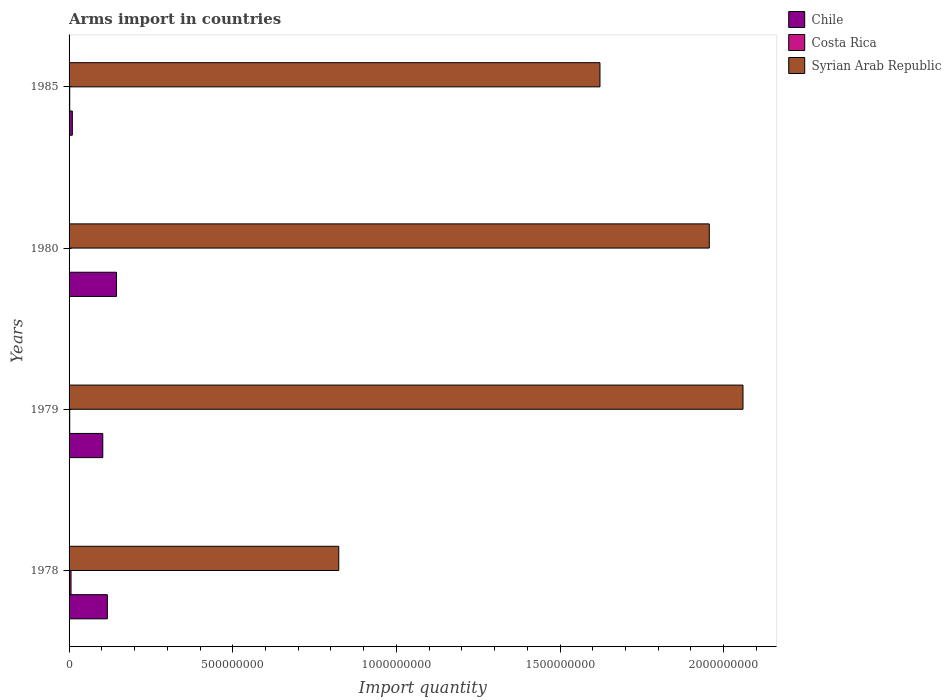How many groups of bars are there?
Offer a very short reply. 4. Are the number of bars per tick equal to the number of legend labels?
Offer a very short reply. Yes. Are the number of bars on each tick of the Y-axis equal?
Offer a terse response. Yes. Across all years, what is the maximum total arms import in Costa Rica?
Your answer should be very brief. 6.00e+06. Across all years, what is the minimum total arms import in Chile?
Provide a succinct answer. 1.00e+07. What is the total total arms import in Syrian Arab Republic in the graph?
Ensure brevity in your answer.  6.46e+09. What is the difference between the total arms import in Chile in 1978 and that in 1979?
Your answer should be compact. 1.40e+07. What is the difference between the total arms import in Chile in 1980 and the total arms import in Costa Rica in 1979?
Provide a succinct answer. 1.43e+08. What is the average total arms import in Costa Rica per year?
Your response must be concise. 2.75e+06. In the year 1978, what is the difference between the total arms import in Costa Rica and total arms import in Chile?
Give a very brief answer. -1.11e+08. Is the total arms import in Costa Rica in 1978 less than that in 1979?
Your answer should be compact. No. What is the difference between the highest and the lowest total arms import in Chile?
Your answer should be very brief. 1.35e+08. Is the sum of the total arms import in Syrian Arab Republic in 1979 and 1980 greater than the maximum total arms import in Costa Rica across all years?
Offer a very short reply. Yes. What does the 1st bar from the bottom in 1980 represents?
Make the answer very short. Chile. Are the values on the major ticks of X-axis written in scientific E-notation?
Your answer should be very brief. No. Does the graph contain grids?
Your answer should be very brief. No. How many legend labels are there?
Provide a short and direct response. 3. How are the legend labels stacked?
Give a very brief answer. Vertical. What is the title of the graph?
Ensure brevity in your answer.  Arms import in countries. Does "Pakistan" appear as one of the legend labels in the graph?
Make the answer very short. No. What is the label or title of the X-axis?
Your response must be concise. Import quantity. What is the label or title of the Y-axis?
Give a very brief answer. Years. What is the Import quantity in Chile in 1978?
Offer a very short reply. 1.17e+08. What is the Import quantity of Syrian Arab Republic in 1978?
Ensure brevity in your answer.  8.24e+08. What is the Import quantity in Chile in 1979?
Offer a terse response. 1.03e+08. What is the Import quantity in Syrian Arab Republic in 1979?
Offer a terse response. 2.06e+09. What is the Import quantity of Chile in 1980?
Your response must be concise. 1.45e+08. What is the Import quantity in Syrian Arab Republic in 1980?
Provide a short and direct response. 1.96e+09. What is the Import quantity in Syrian Arab Republic in 1985?
Your response must be concise. 1.62e+09. Across all years, what is the maximum Import quantity in Chile?
Give a very brief answer. 1.45e+08. Across all years, what is the maximum Import quantity in Costa Rica?
Provide a succinct answer. 6.00e+06. Across all years, what is the maximum Import quantity in Syrian Arab Republic?
Your response must be concise. 2.06e+09. Across all years, what is the minimum Import quantity in Costa Rica?
Provide a short and direct response. 1.00e+06. Across all years, what is the minimum Import quantity of Syrian Arab Republic?
Provide a short and direct response. 8.24e+08. What is the total Import quantity of Chile in the graph?
Keep it short and to the point. 3.75e+08. What is the total Import quantity of Costa Rica in the graph?
Ensure brevity in your answer.  1.10e+07. What is the total Import quantity in Syrian Arab Republic in the graph?
Your response must be concise. 6.46e+09. What is the difference between the Import quantity in Chile in 1978 and that in 1979?
Your answer should be compact. 1.40e+07. What is the difference between the Import quantity of Costa Rica in 1978 and that in 1979?
Provide a short and direct response. 4.00e+06. What is the difference between the Import quantity in Syrian Arab Republic in 1978 and that in 1979?
Make the answer very short. -1.24e+09. What is the difference between the Import quantity in Chile in 1978 and that in 1980?
Offer a terse response. -2.80e+07. What is the difference between the Import quantity of Syrian Arab Republic in 1978 and that in 1980?
Your answer should be very brief. -1.13e+09. What is the difference between the Import quantity of Chile in 1978 and that in 1985?
Keep it short and to the point. 1.07e+08. What is the difference between the Import quantity of Costa Rica in 1978 and that in 1985?
Ensure brevity in your answer.  4.00e+06. What is the difference between the Import quantity of Syrian Arab Republic in 1978 and that in 1985?
Give a very brief answer. -7.98e+08. What is the difference between the Import quantity of Chile in 1979 and that in 1980?
Keep it short and to the point. -4.20e+07. What is the difference between the Import quantity in Syrian Arab Republic in 1979 and that in 1980?
Ensure brevity in your answer.  1.03e+08. What is the difference between the Import quantity in Chile in 1979 and that in 1985?
Offer a very short reply. 9.30e+07. What is the difference between the Import quantity of Costa Rica in 1979 and that in 1985?
Make the answer very short. 0. What is the difference between the Import quantity in Syrian Arab Republic in 1979 and that in 1985?
Keep it short and to the point. 4.37e+08. What is the difference between the Import quantity of Chile in 1980 and that in 1985?
Your response must be concise. 1.35e+08. What is the difference between the Import quantity in Costa Rica in 1980 and that in 1985?
Offer a very short reply. -1.00e+06. What is the difference between the Import quantity in Syrian Arab Republic in 1980 and that in 1985?
Provide a succinct answer. 3.34e+08. What is the difference between the Import quantity in Chile in 1978 and the Import quantity in Costa Rica in 1979?
Offer a very short reply. 1.15e+08. What is the difference between the Import quantity of Chile in 1978 and the Import quantity of Syrian Arab Republic in 1979?
Offer a terse response. -1.94e+09. What is the difference between the Import quantity of Costa Rica in 1978 and the Import quantity of Syrian Arab Republic in 1979?
Provide a short and direct response. -2.05e+09. What is the difference between the Import quantity in Chile in 1978 and the Import quantity in Costa Rica in 1980?
Your response must be concise. 1.16e+08. What is the difference between the Import quantity of Chile in 1978 and the Import quantity of Syrian Arab Republic in 1980?
Provide a succinct answer. -1.84e+09. What is the difference between the Import quantity in Costa Rica in 1978 and the Import quantity in Syrian Arab Republic in 1980?
Give a very brief answer. -1.95e+09. What is the difference between the Import quantity of Chile in 1978 and the Import quantity of Costa Rica in 1985?
Provide a short and direct response. 1.15e+08. What is the difference between the Import quantity in Chile in 1978 and the Import quantity in Syrian Arab Republic in 1985?
Offer a terse response. -1.50e+09. What is the difference between the Import quantity in Costa Rica in 1978 and the Import quantity in Syrian Arab Republic in 1985?
Offer a very short reply. -1.62e+09. What is the difference between the Import quantity in Chile in 1979 and the Import quantity in Costa Rica in 1980?
Give a very brief answer. 1.02e+08. What is the difference between the Import quantity of Chile in 1979 and the Import quantity of Syrian Arab Republic in 1980?
Make the answer very short. -1.85e+09. What is the difference between the Import quantity of Costa Rica in 1979 and the Import quantity of Syrian Arab Republic in 1980?
Your answer should be compact. -1.95e+09. What is the difference between the Import quantity in Chile in 1979 and the Import quantity in Costa Rica in 1985?
Make the answer very short. 1.01e+08. What is the difference between the Import quantity in Chile in 1979 and the Import quantity in Syrian Arab Republic in 1985?
Provide a succinct answer. -1.52e+09. What is the difference between the Import quantity of Costa Rica in 1979 and the Import quantity of Syrian Arab Republic in 1985?
Offer a terse response. -1.62e+09. What is the difference between the Import quantity in Chile in 1980 and the Import quantity in Costa Rica in 1985?
Provide a short and direct response. 1.43e+08. What is the difference between the Import quantity in Chile in 1980 and the Import quantity in Syrian Arab Republic in 1985?
Provide a succinct answer. -1.48e+09. What is the difference between the Import quantity of Costa Rica in 1980 and the Import quantity of Syrian Arab Republic in 1985?
Make the answer very short. -1.62e+09. What is the average Import quantity of Chile per year?
Your response must be concise. 9.38e+07. What is the average Import quantity of Costa Rica per year?
Your response must be concise. 2.75e+06. What is the average Import quantity of Syrian Arab Republic per year?
Your response must be concise. 1.62e+09. In the year 1978, what is the difference between the Import quantity in Chile and Import quantity in Costa Rica?
Offer a very short reply. 1.11e+08. In the year 1978, what is the difference between the Import quantity of Chile and Import quantity of Syrian Arab Republic?
Your response must be concise. -7.07e+08. In the year 1978, what is the difference between the Import quantity in Costa Rica and Import quantity in Syrian Arab Republic?
Your answer should be compact. -8.18e+08. In the year 1979, what is the difference between the Import quantity of Chile and Import quantity of Costa Rica?
Provide a short and direct response. 1.01e+08. In the year 1979, what is the difference between the Import quantity of Chile and Import quantity of Syrian Arab Republic?
Your answer should be very brief. -1.96e+09. In the year 1979, what is the difference between the Import quantity in Costa Rica and Import quantity in Syrian Arab Republic?
Keep it short and to the point. -2.06e+09. In the year 1980, what is the difference between the Import quantity of Chile and Import quantity of Costa Rica?
Keep it short and to the point. 1.44e+08. In the year 1980, what is the difference between the Import quantity of Chile and Import quantity of Syrian Arab Republic?
Offer a very short reply. -1.81e+09. In the year 1980, what is the difference between the Import quantity of Costa Rica and Import quantity of Syrian Arab Republic?
Offer a terse response. -1.96e+09. In the year 1985, what is the difference between the Import quantity in Chile and Import quantity in Syrian Arab Republic?
Offer a terse response. -1.61e+09. In the year 1985, what is the difference between the Import quantity of Costa Rica and Import quantity of Syrian Arab Republic?
Give a very brief answer. -1.62e+09. What is the ratio of the Import quantity in Chile in 1978 to that in 1979?
Your response must be concise. 1.14. What is the ratio of the Import quantity in Costa Rica in 1978 to that in 1979?
Make the answer very short. 3. What is the ratio of the Import quantity in Syrian Arab Republic in 1978 to that in 1979?
Your response must be concise. 0.4. What is the ratio of the Import quantity of Chile in 1978 to that in 1980?
Your answer should be very brief. 0.81. What is the ratio of the Import quantity of Syrian Arab Republic in 1978 to that in 1980?
Offer a terse response. 0.42. What is the ratio of the Import quantity in Syrian Arab Republic in 1978 to that in 1985?
Your answer should be compact. 0.51. What is the ratio of the Import quantity of Chile in 1979 to that in 1980?
Ensure brevity in your answer.  0.71. What is the ratio of the Import quantity of Costa Rica in 1979 to that in 1980?
Ensure brevity in your answer.  2. What is the ratio of the Import quantity in Syrian Arab Republic in 1979 to that in 1980?
Keep it short and to the point. 1.05. What is the ratio of the Import quantity in Chile in 1979 to that in 1985?
Give a very brief answer. 10.3. What is the ratio of the Import quantity of Costa Rica in 1979 to that in 1985?
Offer a terse response. 1. What is the ratio of the Import quantity of Syrian Arab Republic in 1979 to that in 1985?
Provide a short and direct response. 1.27. What is the ratio of the Import quantity of Costa Rica in 1980 to that in 1985?
Keep it short and to the point. 0.5. What is the ratio of the Import quantity of Syrian Arab Republic in 1980 to that in 1985?
Provide a short and direct response. 1.21. What is the difference between the highest and the second highest Import quantity in Chile?
Offer a very short reply. 2.80e+07. What is the difference between the highest and the second highest Import quantity of Costa Rica?
Your answer should be compact. 4.00e+06. What is the difference between the highest and the second highest Import quantity in Syrian Arab Republic?
Give a very brief answer. 1.03e+08. What is the difference between the highest and the lowest Import quantity of Chile?
Your answer should be compact. 1.35e+08. What is the difference between the highest and the lowest Import quantity in Costa Rica?
Offer a terse response. 5.00e+06. What is the difference between the highest and the lowest Import quantity of Syrian Arab Republic?
Your response must be concise. 1.24e+09. 